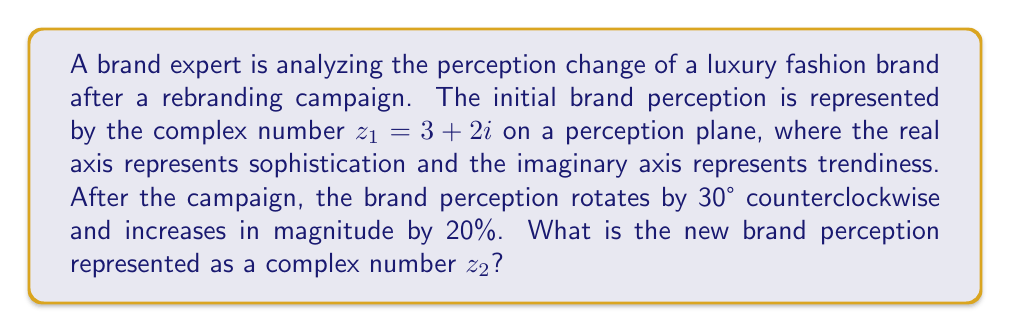Solve this math problem. Let's approach this step-by-step:

1) The initial brand perception is $z_1 = 3 + 2i$.

2) To rotate a complex number by θ degrees counterclockwise, we multiply it by $e^{iθ}$, where θ is in radians. 
   30° = $\frac{\pi}{6}$ radians.

3) The rotation factor is $e^{i\frac{\pi}{6}} = \cos(\frac{\pi}{6}) + i\sin(\frac{\pi}{6}) = \frac{\sqrt{3}}{2} + \frac{1}{2}i$.

4) After rotation (but before scaling), the new complex number would be:
   $z_{rotated} = z_1 \cdot e^{i\frac{\pi}{6}} = (3 + 2i)(\frac{\sqrt{3}}{2} + \frac{1}{2}i)$

5) Multiplying these complex numbers:
   $z_{rotated} = (3 \cdot \frac{\sqrt{3}}{2} - 2 \cdot \frac{1}{2}) + (3 \cdot \frac{1}{2} + 2 \cdot \frac{\sqrt{3}}{2})i$
   $= (\frac{3\sqrt{3}}{2} - 1) + (\frac{3}{2} + \sqrt{3})i$

6) To increase the magnitude by 20%, we multiply by 1.2:
   $z_2 = 1.2 \cdot z_{rotated} = 1.2 \cdot [(\frac{3\sqrt{3}}{2} - 1) + (\frac{3}{2} + \sqrt{3})i]$

7) Simplifying:
   $z_2 = (1.8\sqrt{3} - 1.2) + (1.8 + 1.2\sqrt{3})i$
Answer: $z_2 = (1.8\sqrt{3} - 1.2) + (1.8 + 1.2\sqrt{3})i$ 